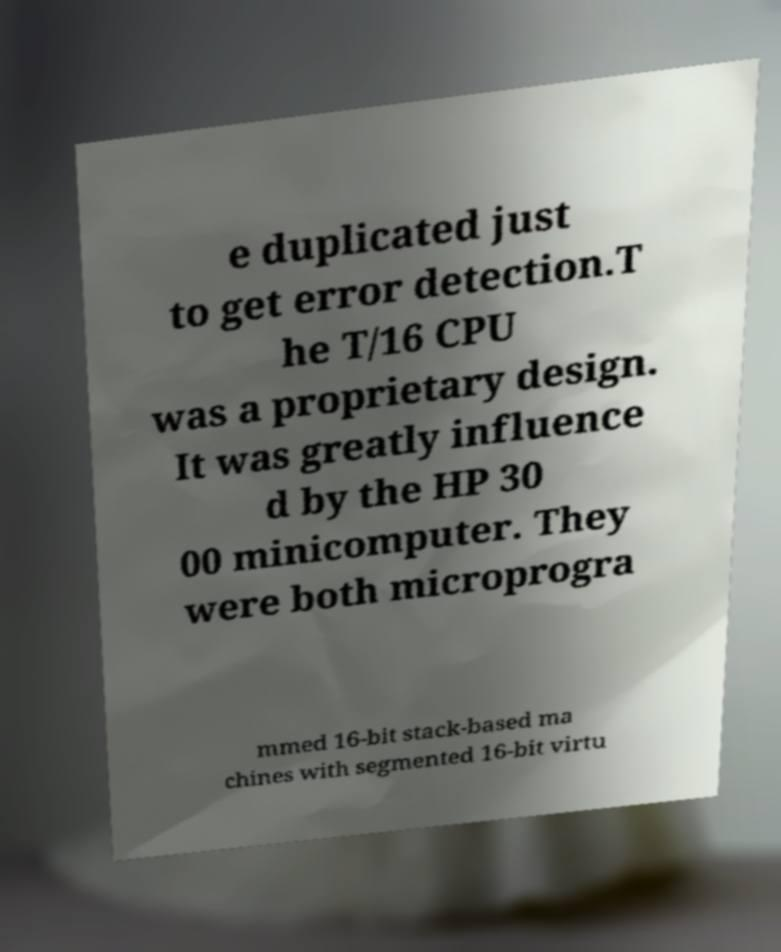Can you read and provide the text displayed in the image?This photo seems to have some interesting text. Can you extract and type it out for me? e duplicated just to get error detection.T he T/16 CPU was a proprietary design. It was greatly influence d by the HP 30 00 minicomputer. They were both microprogra mmed 16-bit stack-based ma chines with segmented 16-bit virtu 